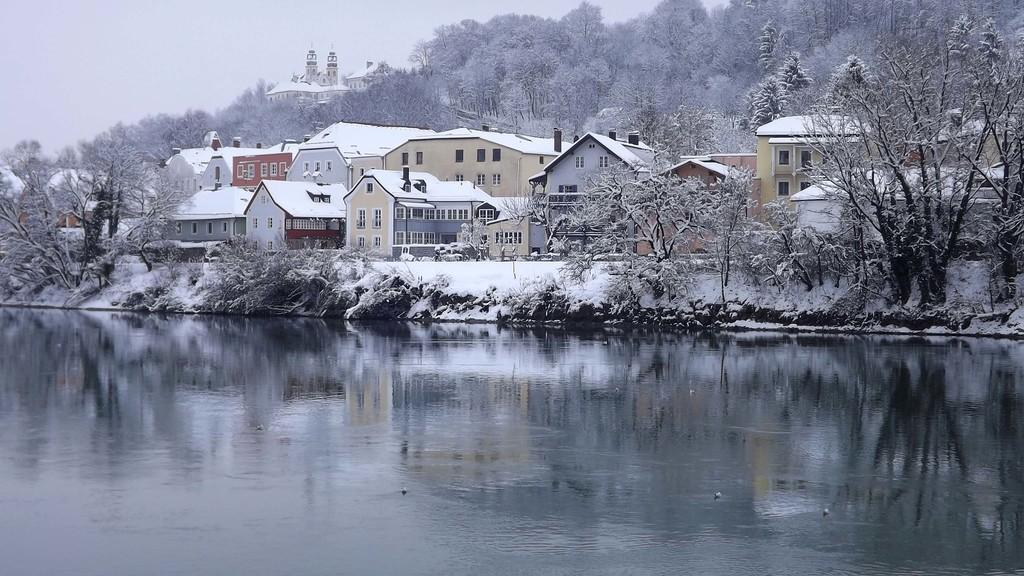What is at the bottom of the image? There is water at the bottom of the image. What can be seen in the background of the image? There are houses and trees with snow in the background of the image. What is visible at the top of the image? The sky is visible at the top of the image. Where is the net located in the image? There is no net present in the image. Can you tell me what the judge is wearing in the image? There is no judge present in the image. 